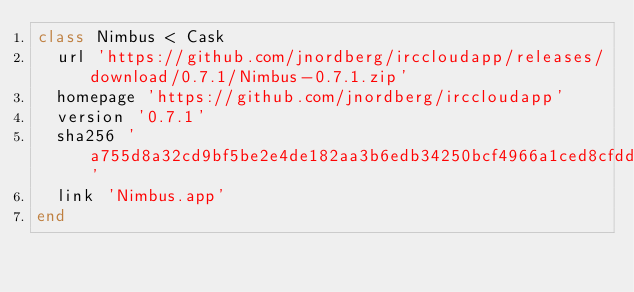Convert code to text. <code><loc_0><loc_0><loc_500><loc_500><_Ruby_>class Nimbus < Cask
  url 'https://github.com/jnordberg/irccloudapp/releases/download/0.7.1/Nimbus-0.7.1.zip'
  homepage 'https://github.com/jnordberg/irccloudapp'
  version '0.7.1'
  sha256 'a755d8a32cd9bf5be2e4de182aa3b6edb34250bcf4966a1ced8cfdd19911e1a3'
  link 'Nimbus.app'
end
</code> 